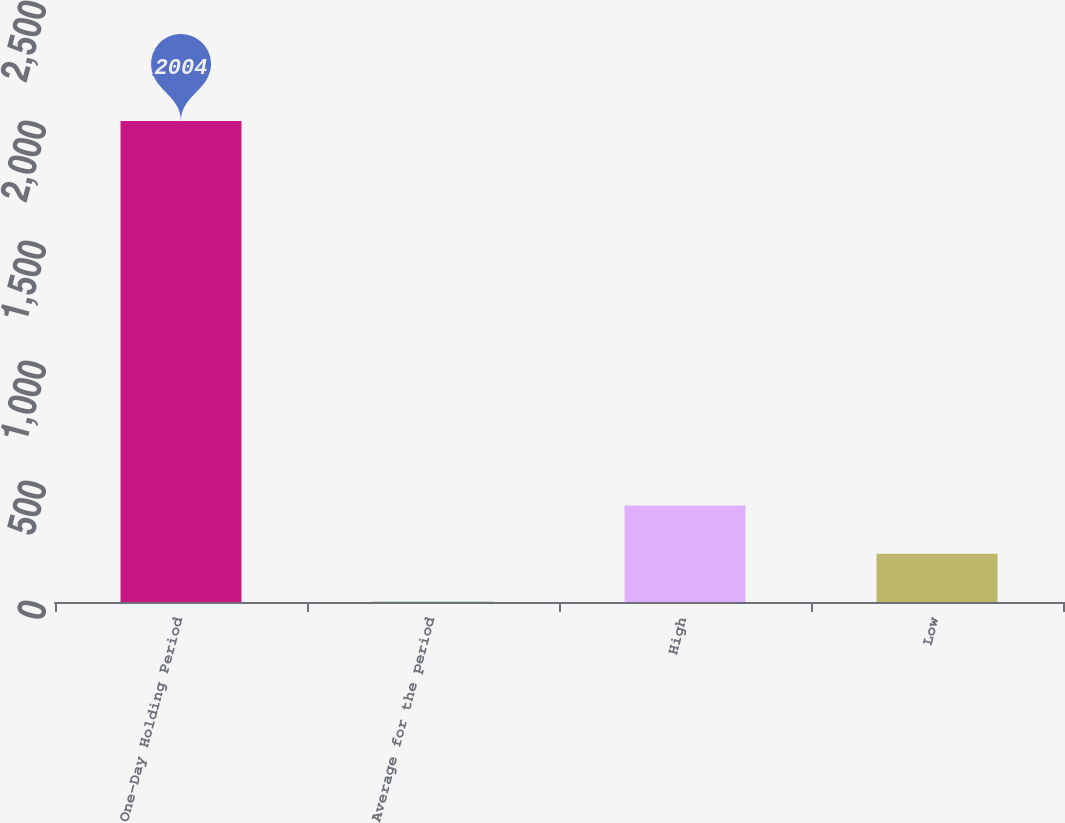<chart> <loc_0><loc_0><loc_500><loc_500><bar_chart><fcel>One-Day Holding Period<fcel>Average for the period<fcel>High<fcel>Low<nl><fcel>2004<fcel>1<fcel>401.6<fcel>201.3<nl></chart> 